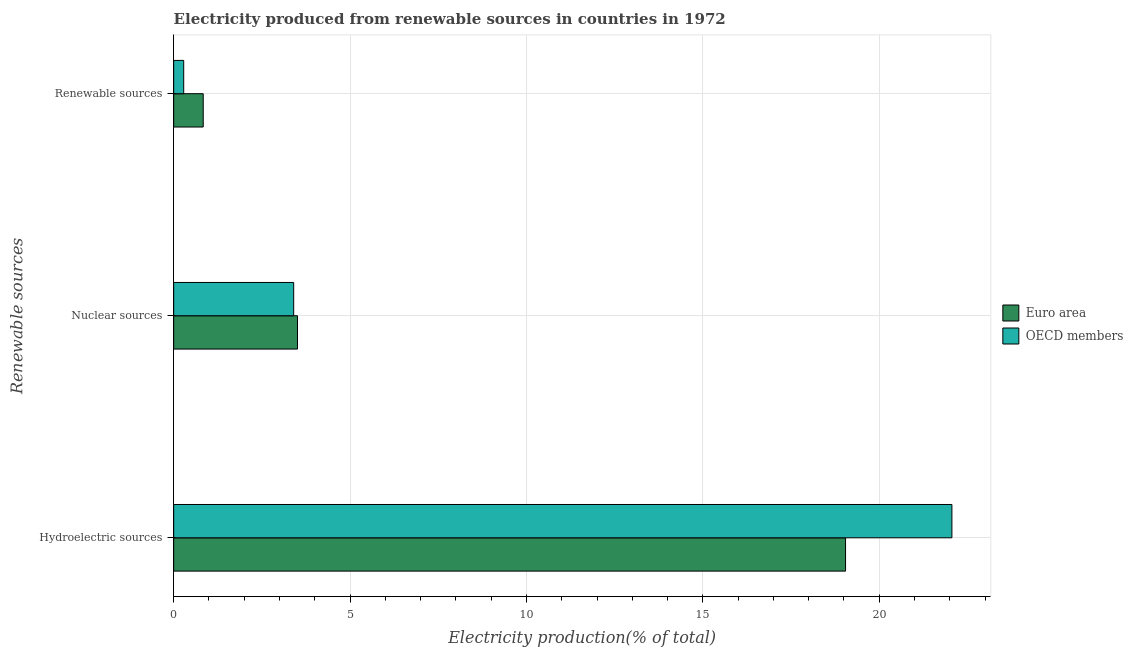How many different coloured bars are there?
Your answer should be compact. 2. How many groups of bars are there?
Provide a succinct answer. 3. Are the number of bars per tick equal to the number of legend labels?
Ensure brevity in your answer.  Yes. Are the number of bars on each tick of the Y-axis equal?
Ensure brevity in your answer.  Yes. How many bars are there on the 3rd tick from the top?
Your answer should be very brief. 2. What is the label of the 1st group of bars from the top?
Ensure brevity in your answer.  Renewable sources. What is the percentage of electricity produced by hydroelectric sources in OECD members?
Provide a short and direct response. 22.06. Across all countries, what is the maximum percentage of electricity produced by nuclear sources?
Your response must be concise. 3.51. Across all countries, what is the minimum percentage of electricity produced by hydroelectric sources?
Provide a succinct answer. 19.05. What is the total percentage of electricity produced by hydroelectric sources in the graph?
Make the answer very short. 41.11. What is the difference between the percentage of electricity produced by nuclear sources in OECD members and that in Euro area?
Offer a terse response. -0.11. What is the difference between the percentage of electricity produced by renewable sources in Euro area and the percentage of electricity produced by nuclear sources in OECD members?
Offer a terse response. -2.56. What is the average percentage of electricity produced by nuclear sources per country?
Your answer should be very brief. 3.46. What is the difference between the percentage of electricity produced by hydroelectric sources and percentage of electricity produced by nuclear sources in OECD members?
Keep it short and to the point. 18.66. What is the ratio of the percentage of electricity produced by nuclear sources in OECD members to that in Euro area?
Your response must be concise. 0.97. Is the percentage of electricity produced by renewable sources in OECD members less than that in Euro area?
Keep it short and to the point. Yes. What is the difference between the highest and the second highest percentage of electricity produced by hydroelectric sources?
Ensure brevity in your answer.  3.01. What is the difference between the highest and the lowest percentage of electricity produced by nuclear sources?
Keep it short and to the point. 0.11. In how many countries, is the percentage of electricity produced by hydroelectric sources greater than the average percentage of electricity produced by hydroelectric sources taken over all countries?
Give a very brief answer. 1. Is the sum of the percentage of electricity produced by nuclear sources in OECD members and Euro area greater than the maximum percentage of electricity produced by hydroelectric sources across all countries?
Your answer should be compact. No. What does the 1st bar from the bottom in Nuclear sources represents?
Offer a terse response. Euro area. Is it the case that in every country, the sum of the percentage of electricity produced by hydroelectric sources and percentage of electricity produced by nuclear sources is greater than the percentage of electricity produced by renewable sources?
Give a very brief answer. Yes. Are all the bars in the graph horizontal?
Keep it short and to the point. Yes. Are the values on the major ticks of X-axis written in scientific E-notation?
Your response must be concise. No. Where does the legend appear in the graph?
Provide a succinct answer. Center right. What is the title of the graph?
Provide a short and direct response. Electricity produced from renewable sources in countries in 1972. Does "Botswana" appear as one of the legend labels in the graph?
Your answer should be very brief. No. What is the label or title of the X-axis?
Your answer should be compact. Electricity production(% of total). What is the label or title of the Y-axis?
Keep it short and to the point. Renewable sources. What is the Electricity production(% of total) of Euro area in Hydroelectric sources?
Offer a terse response. 19.05. What is the Electricity production(% of total) in OECD members in Hydroelectric sources?
Keep it short and to the point. 22.06. What is the Electricity production(% of total) in Euro area in Nuclear sources?
Make the answer very short. 3.51. What is the Electricity production(% of total) in OECD members in Nuclear sources?
Give a very brief answer. 3.4. What is the Electricity production(% of total) of Euro area in Renewable sources?
Offer a very short reply. 0.84. What is the Electricity production(% of total) in OECD members in Renewable sources?
Provide a succinct answer. 0.28. Across all Renewable sources, what is the maximum Electricity production(% of total) of Euro area?
Keep it short and to the point. 19.05. Across all Renewable sources, what is the maximum Electricity production(% of total) in OECD members?
Your response must be concise. 22.06. Across all Renewable sources, what is the minimum Electricity production(% of total) in Euro area?
Your answer should be compact. 0.84. Across all Renewable sources, what is the minimum Electricity production(% of total) in OECD members?
Offer a very short reply. 0.28. What is the total Electricity production(% of total) in Euro area in the graph?
Provide a short and direct response. 23.39. What is the total Electricity production(% of total) in OECD members in the graph?
Provide a succinct answer. 25.75. What is the difference between the Electricity production(% of total) of Euro area in Hydroelectric sources and that in Nuclear sources?
Keep it short and to the point. 15.54. What is the difference between the Electricity production(% of total) in OECD members in Hydroelectric sources and that in Nuclear sources?
Provide a short and direct response. 18.66. What is the difference between the Electricity production(% of total) of Euro area in Hydroelectric sources and that in Renewable sources?
Provide a short and direct response. 18.21. What is the difference between the Electricity production(% of total) in OECD members in Hydroelectric sources and that in Renewable sources?
Provide a succinct answer. 21.78. What is the difference between the Electricity production(% of total) in Euro area in Nuclear sources and that in Renewable sources?
Provide a short and direct response. 2.67. What is the difference between the Electricity production(% of total) in OECD members in Nuclear sources and that in Renewable sources?
Your answer should be compact. 3.12. What is the difference between the Electricity production(% of total) of Euro area in Hydroelectric sources and the Electricity production(% of total) of OECD members in Nuclear sources?
Give a very brief answer. 15.64. What is the difference between the Electricity production(% of total) in Euro area in Hydroelectric sources and the Electricity production(% of total) in OECD members in Renewable sources?
Ensure brevity in your answer.  18.76. What is the difference between the Electricity production(% of total) in Euro area in Nuclear sources and the Electricity production(% of total) in OECD members in Renewable sources?
Offer a very short reply. 3.23. What is the average Electricity production(% of total) of Euro area per Renewable sources?
Your response must be concise. 7.8. What is the average Electricity production(% of total) of OECD members per Renewable sources?
Offer a very short reply. 8.58. What is the difference between the Electricity production(% of total) in Euro area and Electricity production(% of total) in OECD members in Hydroelectric sources?
Your response must be concise. -3.01. What is the difference between the Electricity production(% of total) in Euro area and Electricity production(% of total) in OECD members in Nuclear sources?
Offer a terse response. 0.11. What is the difference between the Electricity production(% of total) of Euro area and Electricity production(% of total) of OECD members in Renewable sources?
Provide a succinct answer. 0.55. What is the ratio of the Electricity production(% of total) in Euro area in Hydroelectric sources to that in Nuclear sources?
Provide a succinct answer. 5.43. What is the ratio of the Electricity production(% of total) of OECD members in Hydroelectric sources to that in Nuclear sources?
Your response must be concise. 6.48. What is the ratio of the Electricity production(% of total) of Euro area in Hydroelectric sources to that in Renewable sources?
Keep it short and to the point. 22.75. What is the ratio of the Electricity production(% of total) of OECD members in Hydroelectric sources to that in Renewable sources?
Your answer should be compact. 77.57. What is the ratio of the Electricity production(% of total) in Euro area in Nuclear sources to that in Renewable sources?
Provide a succinct answer. 4.19. What is the ratio of the Electricity production(% of total) in OECD members in Nuclear sources to that in Renewable sources?
Your response must be concise. 11.96. What is the difference between the highest and the second highest Electricity production(% of total) in Euro area?
Ensure brevity in your answer.  15.54. What is the difference between the highest and the second highest Electricity production(% of total) of OECD members?
Provide a succinct answer. 18.66. What is the difference between the highest and the lowest Electricity production(% of total) of Euro area?
Make the answer very short. 18.21. What is the difference between the highest and the lowest Electricity production(% of total) of OECD members?
Your answer should be very brief. 21.78. 